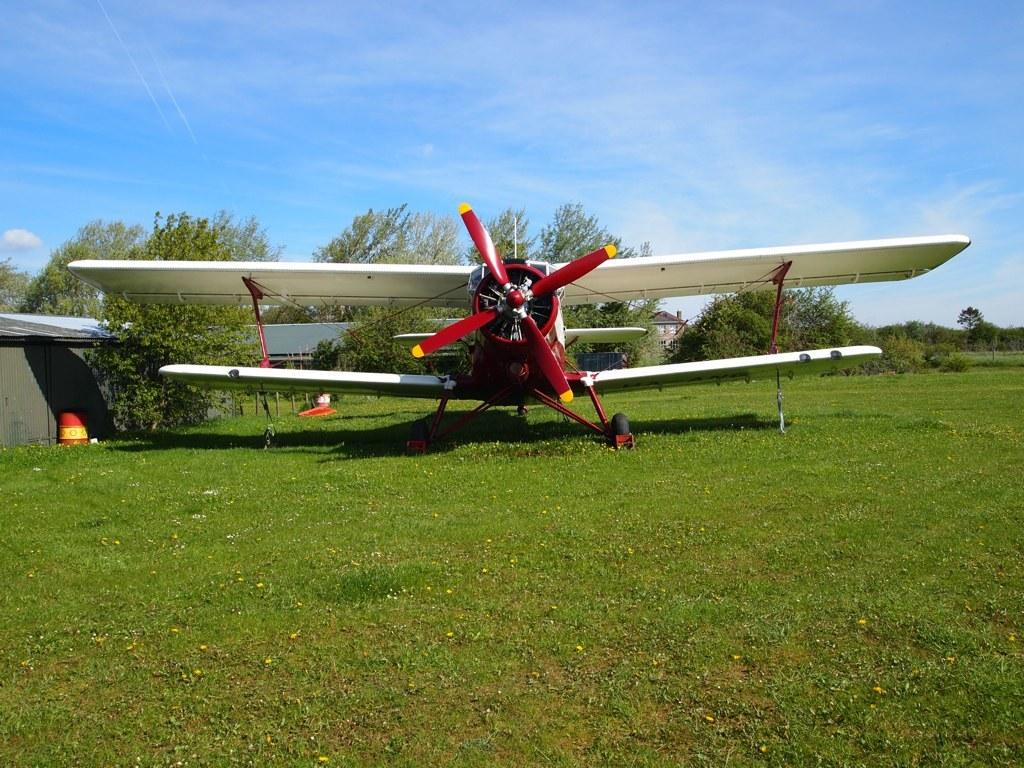What is the main subject of the image? The main subject of the image is an airplane. Where is the airplane located? The airplane is on the grass. What can be seen in the background of the image? There are trees, houses, and the sky visible in the background of the image. Can you see any fairies flying around the airplane in the image? There are no fairies present in the image. What is the reason for the airplane being on the grass in the image? The facts provided do not give any information about the reason for the airplane being on the grass. --- 